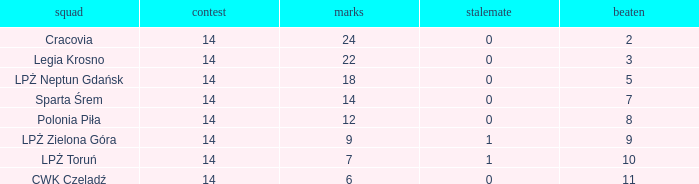What is the lowest points for a match before 14? None. 